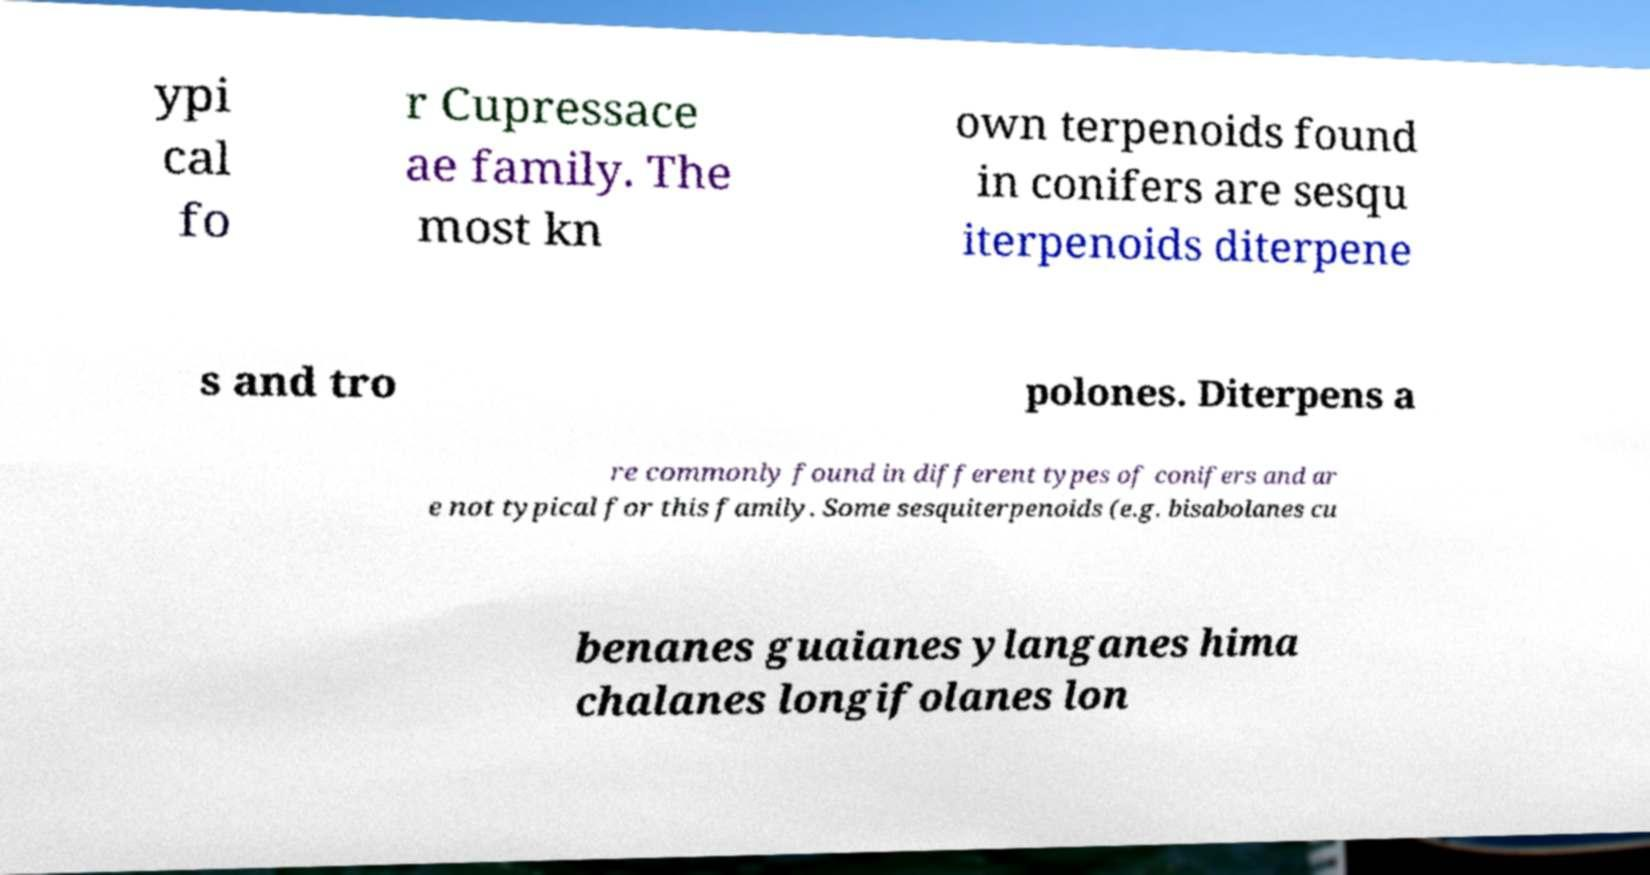There's text embedded in this image that I need extracted. Can you transcribe it verbatim? ypi cal fo r Cupressace ae family. The most kn own terpenoids found in conifers are sesqu iterpenoids diterpene s and tro polones. Diterpens a re commonly found in different types of conifers and ar e not typical for this family. Some sesquiterpenoids (e.g. bisabolanes cu benanes guaianes ylanganes hima chalanes longifolanes lon 